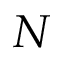<formula> <loc_0><loc_0><loc_500><loc_500>N</formula> 